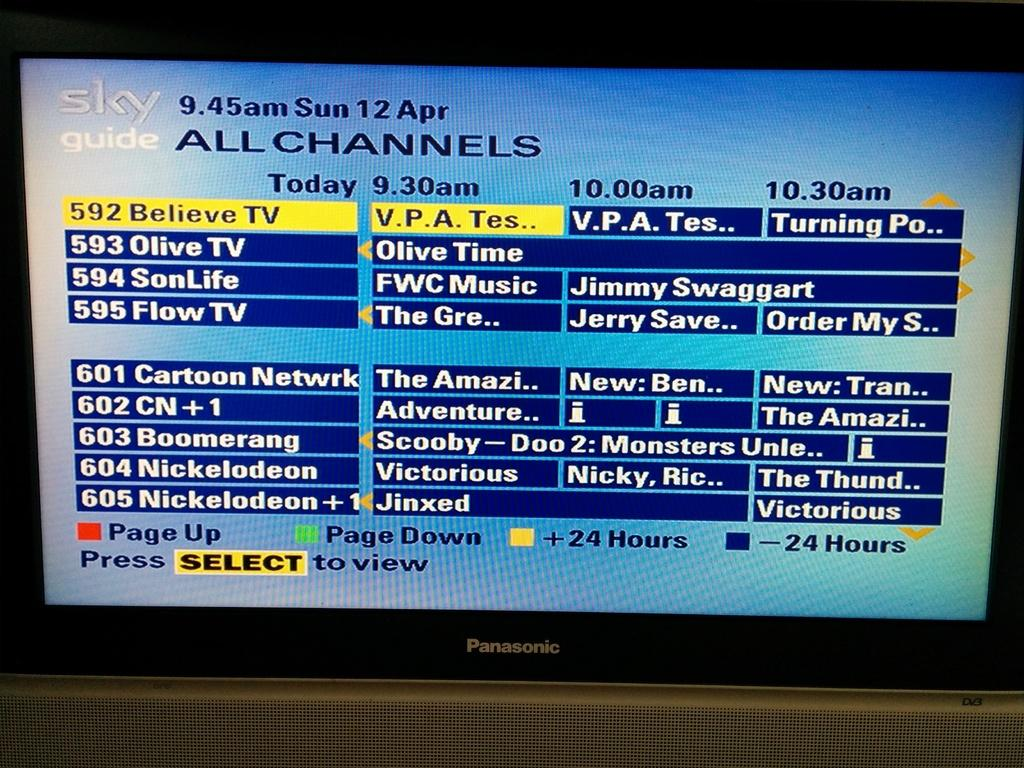<image>
Provide a brief description of the given image. A Panasonic TV is displaying the Sky Guide Channels 